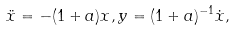<formula> <loc_0><loc_0><loc_500><loc_500>\ddot { x } = - ( 1 + a ) x , y = ( 1 + a ) ^ { - 1 } \dot { x } ,</formula> 